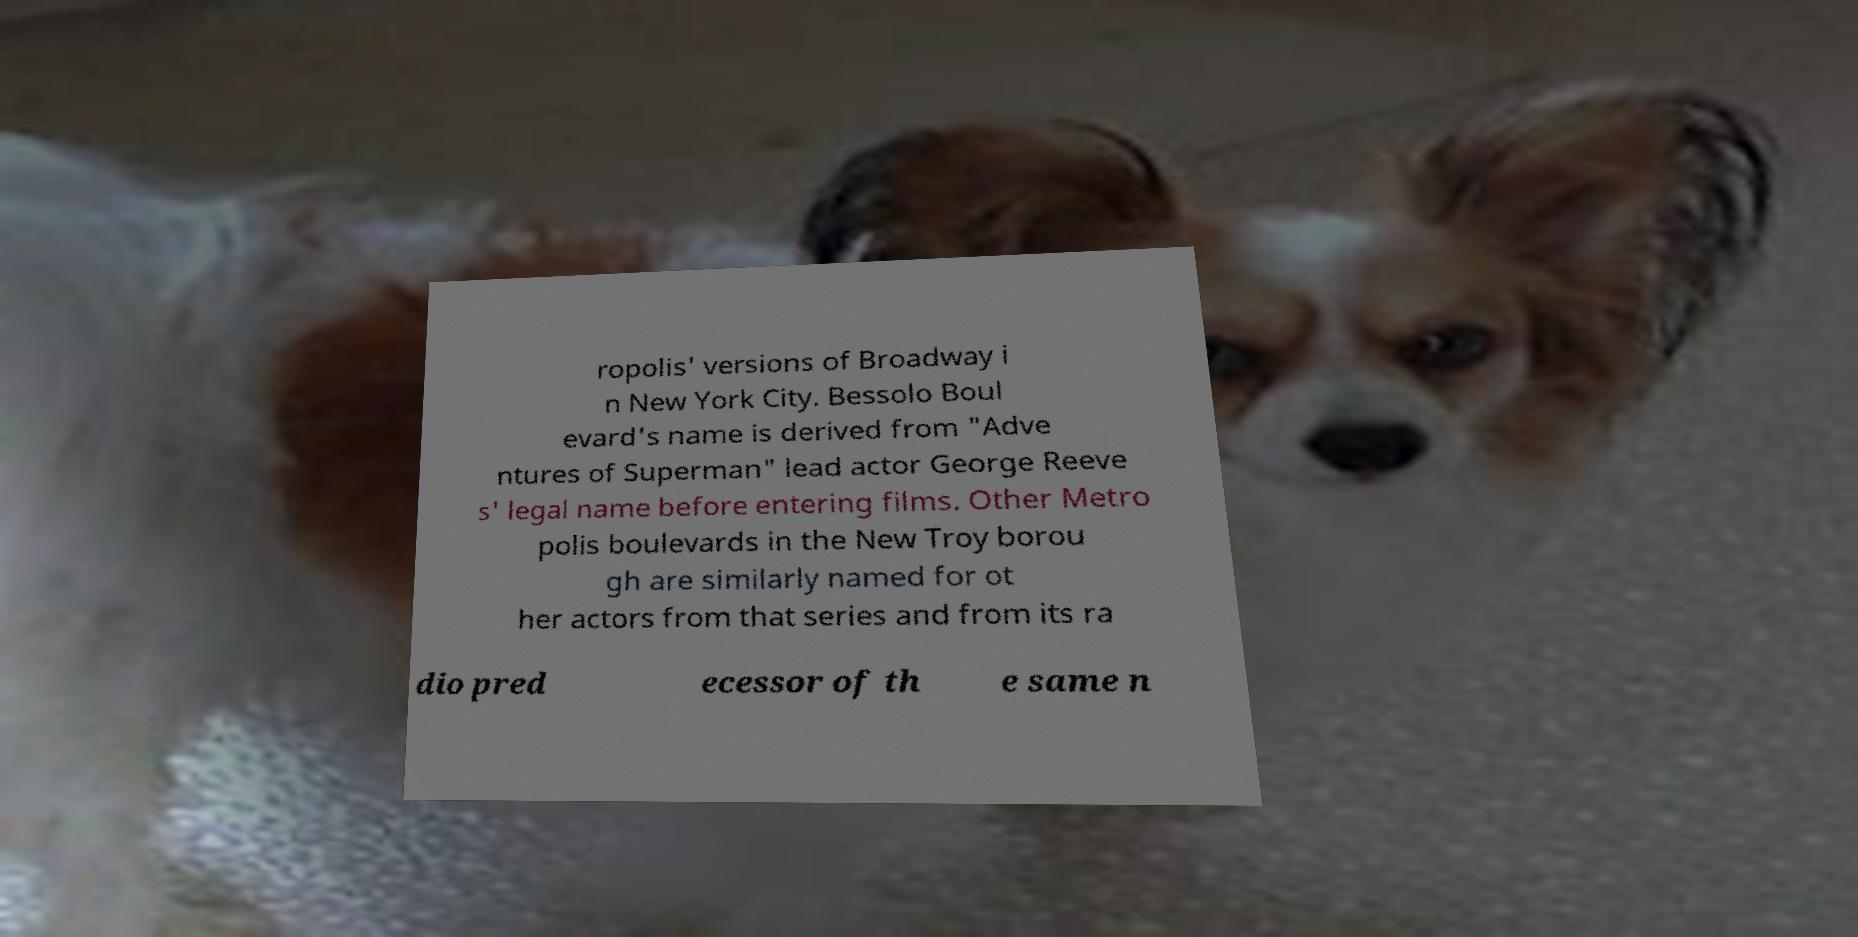There's text embedded in this image that I need extracted. Can you transcribe it verbatim? ropolis' versions of Broadway i n New York City. Bessolo Boul evard's name is derived from "Adve ntures of Superman" lead actor George Reeve s' legal name before entering films. Other Metro polis boulevards in the New Troy borou gh are similarly named for ot her actors from that series and from its ra dio pred ecessor of th e same n 